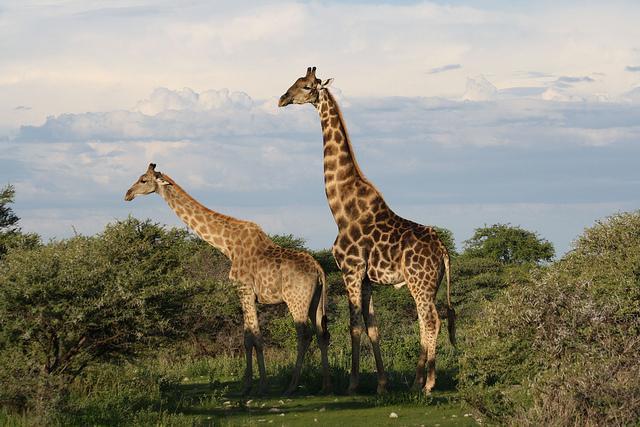How many giraffes are there?
Give a very brief answer. 2. How many giraffes in the field?
Give a very brief answer. 2. How many giraffes are in the photo?
Give a very brief answer. 2. How many people are on the slope?
Give a very brief answer. 0. 